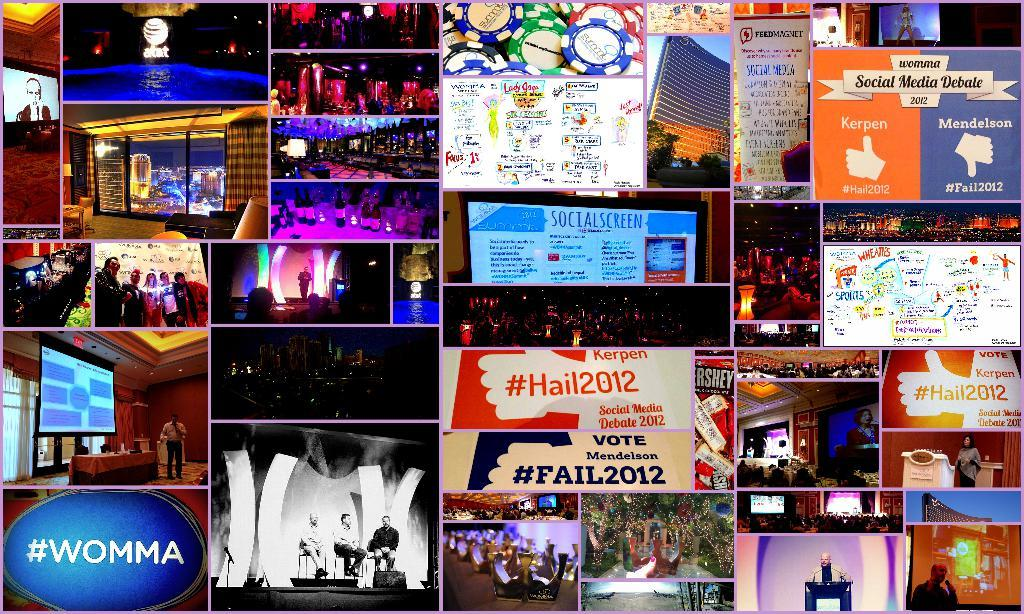<image>
Provide a brief description of the given image. A collection of what happened during the Hail2012 Social media debate. 